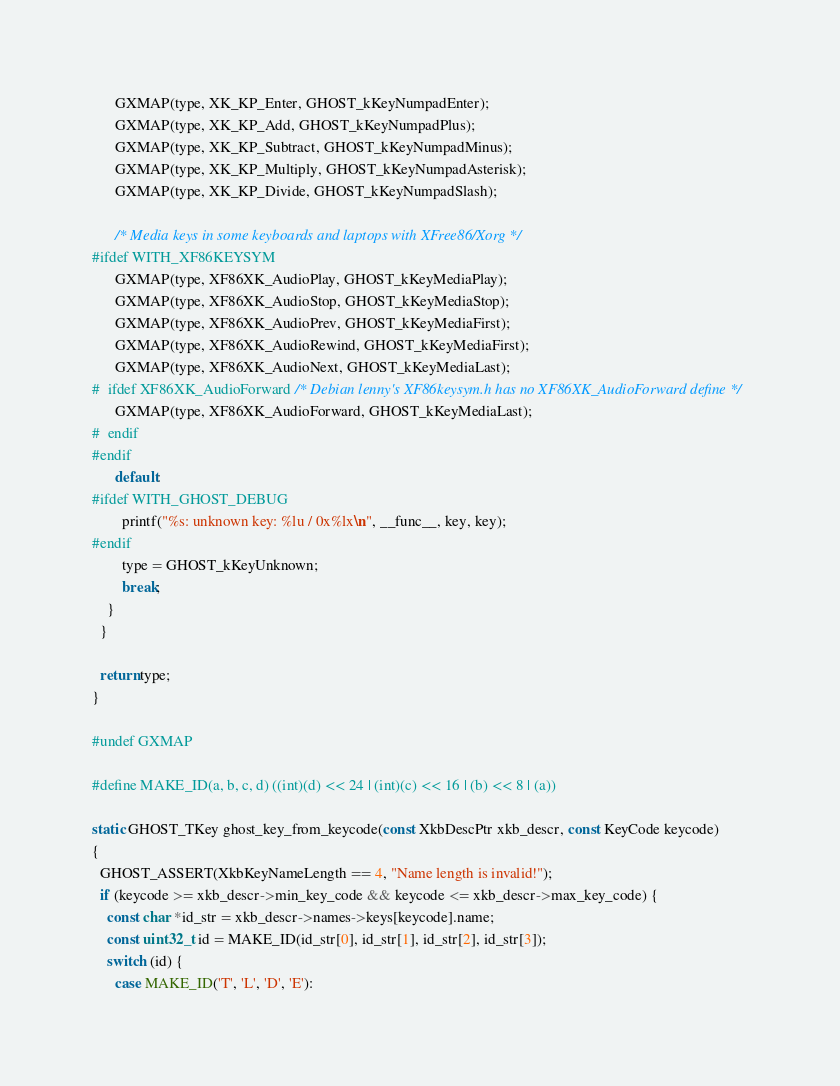Convert code to text. <code><loc_0><loc_0><loc_500><loc_500><_C++_>
      GXMAP(type, XK_KP_Enter, GHOST_kKeyNumpadEnter);
      GXMAP(type, XK_KP_Add, GHOST_kKeyNumpadPlus);
      GXMAP(type, XK_KP_Subtract, GHOST_kKeyNumpadMinus);
      GXMAP(type, XK_KP_Multiply, GHOST_kKeyNumpadAsterisk);
      GXMAP(type, XK_KP_Divide, GHOST_kKeyNumpadSlash);

      /* Media keys in some keyboards and laptops with XFree86/Xorg */
#ifdef WITH_XF86KEYSYM
      GXMAP(type, XF86XK_AudioPlay, GHOST_kKeyMediaPlay);
      GXMAP(type, XF86XK_AudioStop, GHOST_kKeyMediaStop);
      GXMAP(type, XF86XK_AudioPrev, GHOST_kKeyMediaFirst);
      GXMAP(type, XF86XK_AudioRewind, GHOST_kKeyMediaFirst);
      GXMAP(type, XF86XK_AudioNext, GHOST_kKeyMediaLast);
#  ifdef XF86XK_AudioForward /* Debian lenny's XF86keysym.h has no XF86XK_AudioForward define */
      GXMAP(type, XF86XK_AudioForward, GHOST_kKeyMediaLast);
#  endif
#endif
      default:
#ifdef WITH_GHOST_DEBUG
        printf("%s: unknown key: %lu / 0x%lx\n", __func__, key, key);
#endif
        type = GHOST_kKeyUnknown;
        break;
    }
  }

  return type;
}

#undef GXMAP

#define MAKE_ID(a, b, c, d) ((int)(d) << 24 | (int)(c) << 16 | (b) << 8 | (a))

static GHOST_TKey ghost_key_from_keycode(const XkbDescPtr xkb_descr, const KeyCode keycode)
{
  GHOST_ASSERT(XkbKeyNameLength == 4, "Name length is invalid!");
  if (keycode >= xkb_descr->min_key_code && keycode <= xkb_descr->max_key_code) {
    const char *id_str = xkb_descr->names->keys[keycode].name;
    const uint32_t id = MAKE_ID(id_str[0], id_str[1], id_str[2], id_str[3]);
    switch (id) {
      case MAKE_ID('T', 'L', 'D', 'E'):</code> 